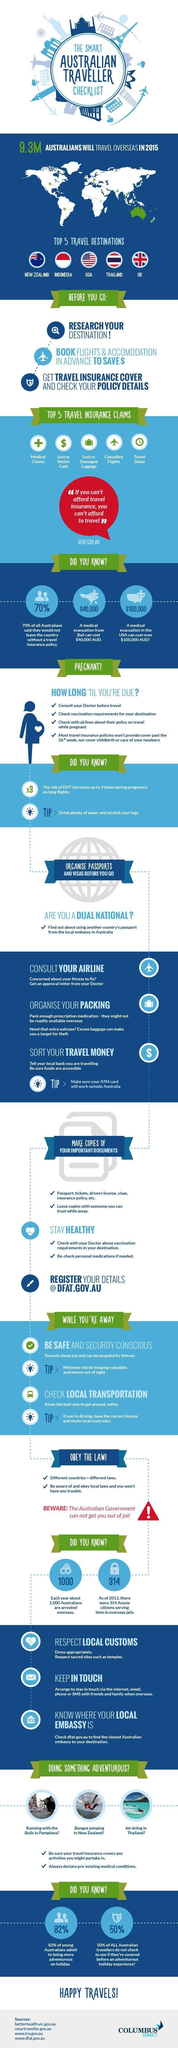Which country has highest medical evacuation cost?
Answer the question with a short phrase. USA What percentage of young australians are not adventurous during holiday? 18% 